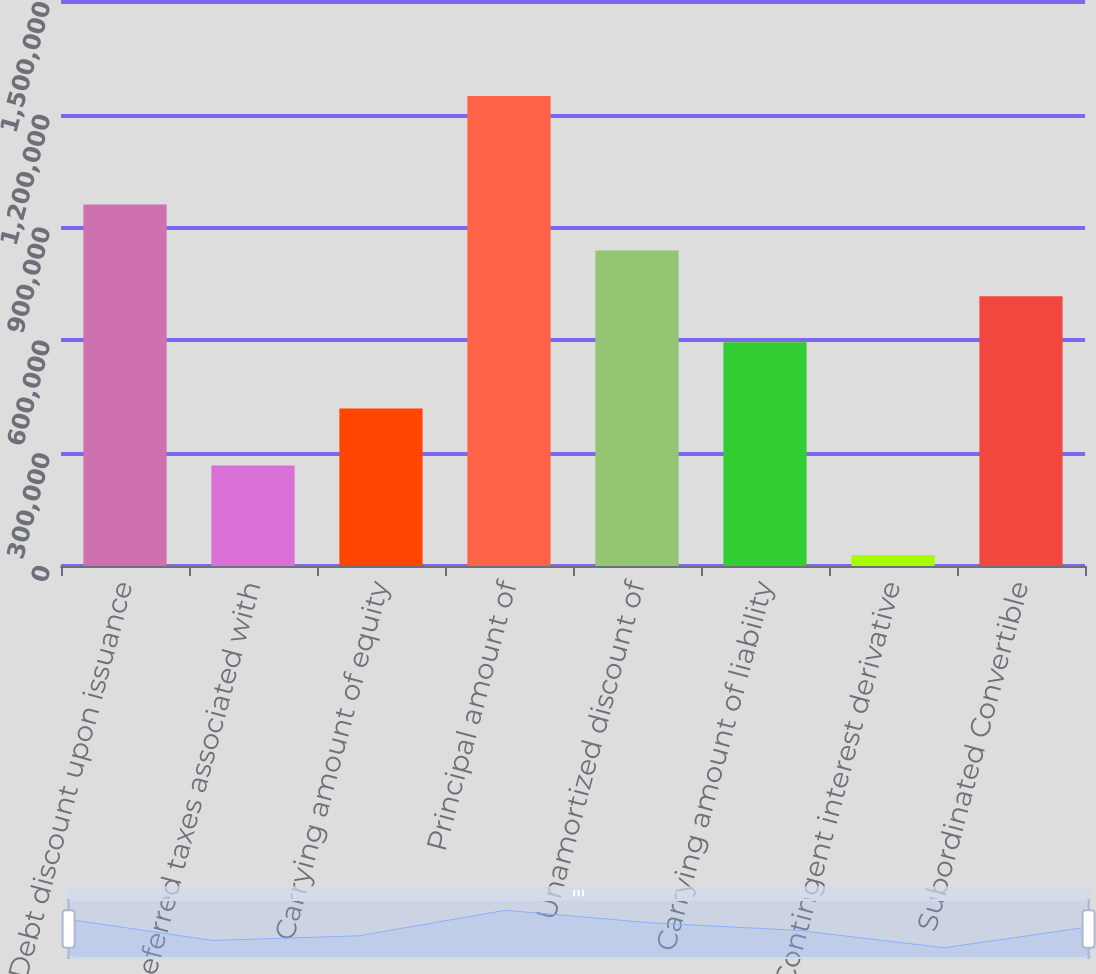<chart> <loc_0><loc_0><loc_500><loc_500><bar_chart><fcel>Debt discount upon issuance<fcel>Deferred taxes associated with<fcel>Carrying amount of equity<fcel>Principal amount of<fcel>Unamortized discount of<fcel>Carrying amount of liability<fcel>Contingent interest derivative<fcel>Subordinated Convertible<nl><fcel>961351<fcel>267225<fcel>418996<fcel>1.25e+06<fcel>839251<fcel>595052<fcel>29004<fcel>717152<nl></chart> 